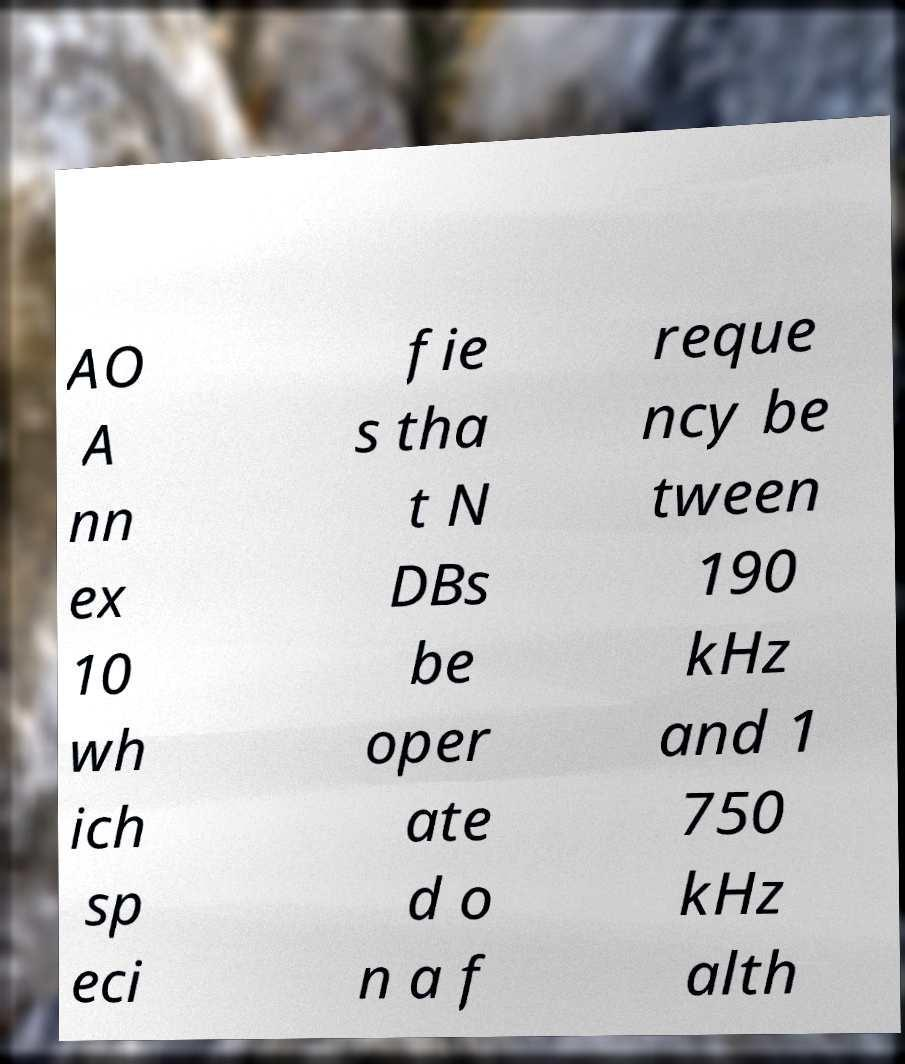Could you assist in decoding the text presented in this image and type it out clearly? AO A nn ex 10 wh ich sp eci fie s tha t N DBs be oper ate d o n a f reque ncy be tween 190 kHz and 1 750 kHz alth 